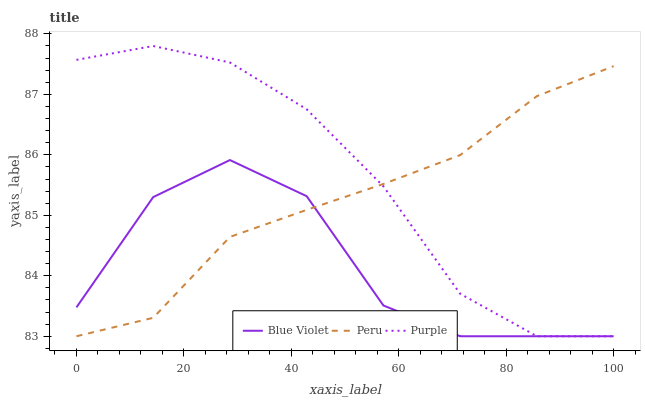Does Blue Violet have the minimum area under the curve?
Answer yes or no. Yes. Does Purple have the maximum area under the curve?
Answer yes or no. Yes. Does Peru have the minimum area under the curve?
Answer yes or no. No. Does Peru have the maximum area under the curve?
Answer yes or no. No. Is Peru the smoothest?
Answer yes or no. Yes. Is Blue Violet the roughest?
Answer yes or no. Yes. Is Blue Violet the smoothest?
Answer yes or no. No. Is Peru the roughest?
Answer yes or no. No. Does Purple have the lowest value?
Answer yes or no. Yes. Does Purple have the highest value?
Answer yes or no. Yes. Does Peru have the highest value?
Answer yes or no. No. Does Peru intersect Purple?
Answer yes or no. Yes. Is Peru less than Purple?
Answer yes or no. No. Is Peru greater than Purple?
Answer yes or no. No. 